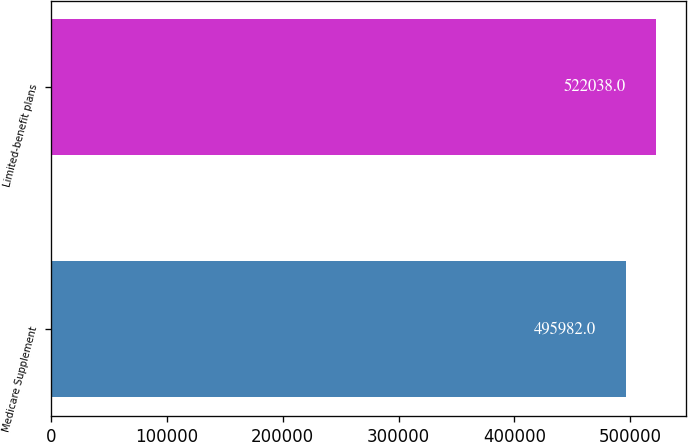Convert chart. <chart><loc_0><loc_0><loc_500><loc_500><bar_chart><fcel>Medicare Supplement<fcel>Limited-benefit plans<nl><fcel>495982<fcel>522038<nl></chart> 